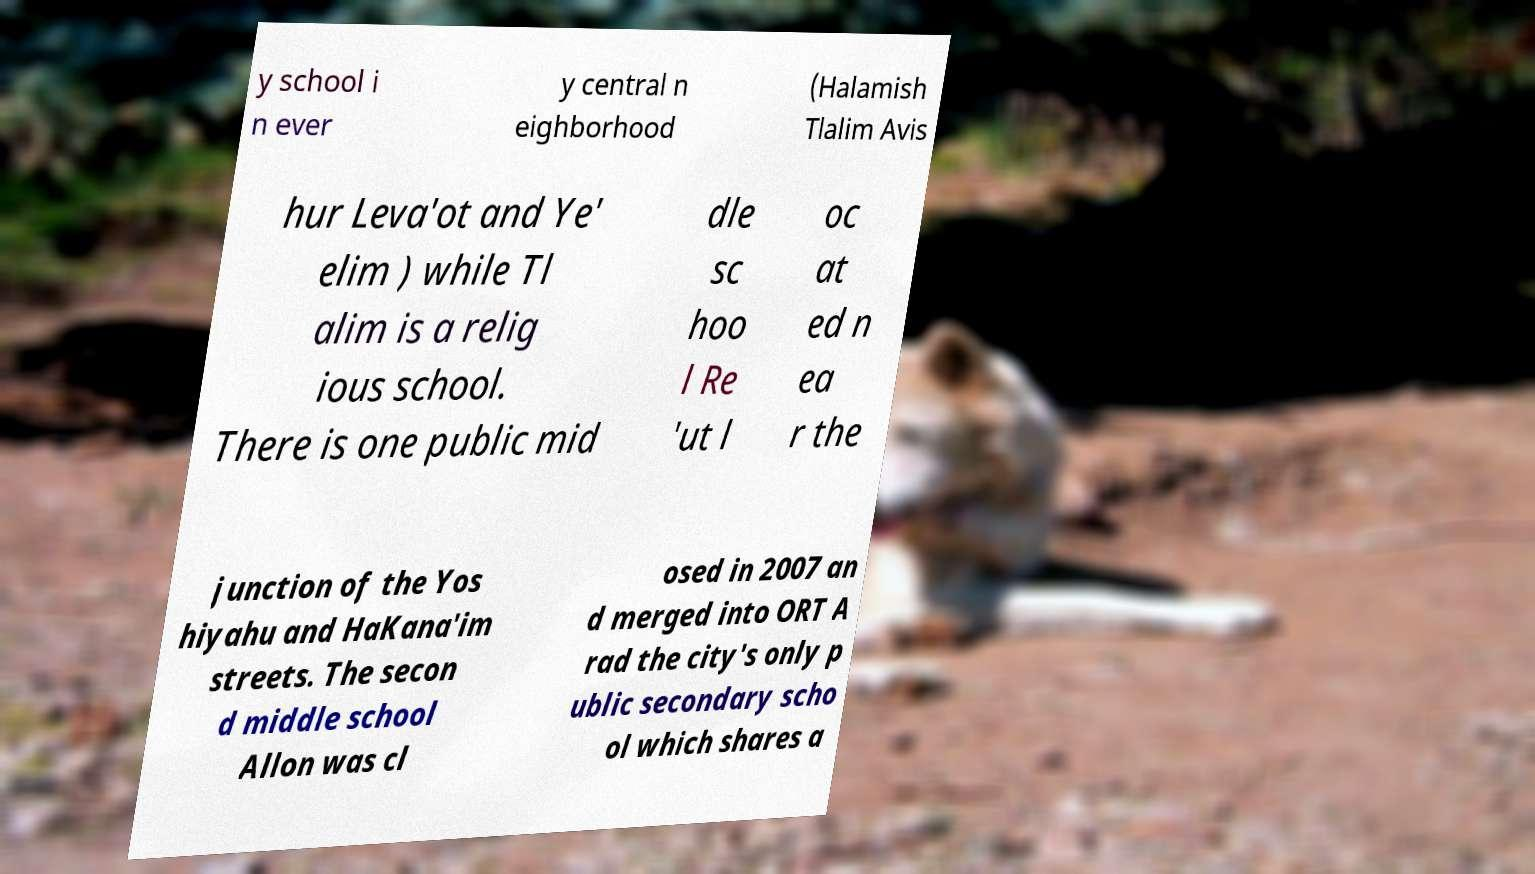What messages or text are displayed in this image? I need them in a readable, typed format. y school i n ever y central n eighborhood (Halamish Tlalim Avis hur Leva'ot and Ye' elim ) while Tl alim is a relig ious school. There is one public mid dle sc hoo l Re 'ut l oc at ed n ea r the junction of the Yos hiyahu and HaKana'im streets. The secon d middle school Allon was cl osed in 2007 an d merged into ORT A rad the city's only p ublic secondary scho ol which shares a 